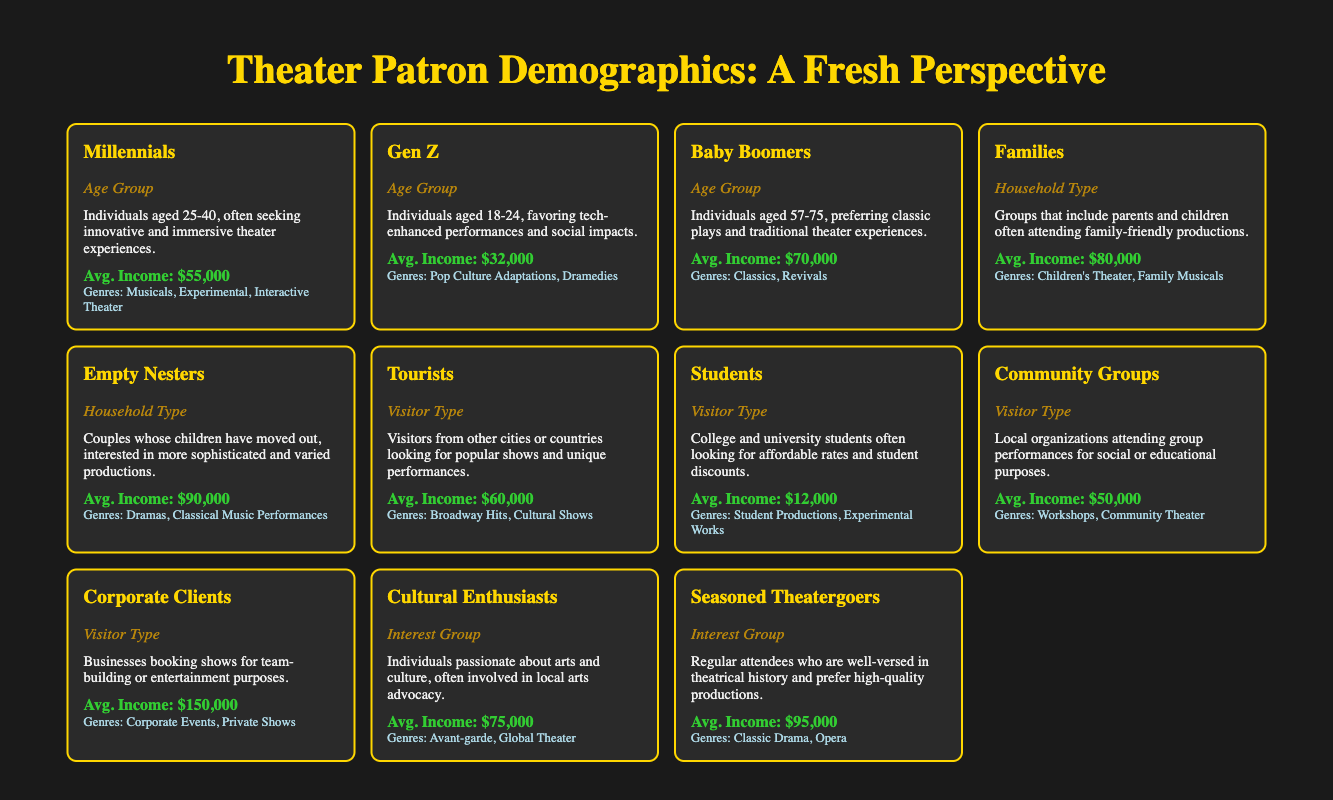What's the average income for Millennials? The average income for Millennials is listed in the table as $55,000. Simply read the value corresponding to this group.
Answer: $55,000 Which demographic is most likely to attend Children's Theater? The group that is most likely to attend Children's Theater is Families, as noted in the table under Likely Genres.
Answer: Families Is Gen Z interested in Classic Drama productions? No, Gen Z is not interested in Classic Drama productions. The table shows that their likely genres include Pop Culture Adaptations and Dramedies, not Classic Drama.
Answer: No What is the combined average income of Empty Nesters and Corporate Clients? To find the combined average income, add the average income of Empty Nesters ($90,000) and Corporate Clients ($150,000), which equals $240,000.
Answer: $240,000 Which age group has the lowest average income? The age group with the lowest average income is Students, as their average income in the table is $12,000. This value is lower than those of other age groups.
Answer: Students Are tourists more likely to attend Broadway Hits or Dramedies? Yes, tourists are more likely to attend Broadway Hits, as it is listed under their likely genres. Dramedies are associated with Gen Z, not tourists.
Answer: Yes What's the average income difference between Baby Boomers and Millennials? The average income for Baby Boomers is $70,000 and that for Millennials is $55,000. The difference is calculated as $70,000 - $55,000 = $15,000.
Answer: $15,000 Which visitor type has the highest average income? The visitor type with the highest average income is Corporate Clients at $150,000, higher than any other groups listed in the table.
Answer: Corporate Clients How many groups have an average income above $70,000? There are four groups with an average income above $70,000: Baby Boomers, Families, Empty Nesters, and Corporate Clients. Each of their average incomes listed exceeds this threshold.
Answer: Four 